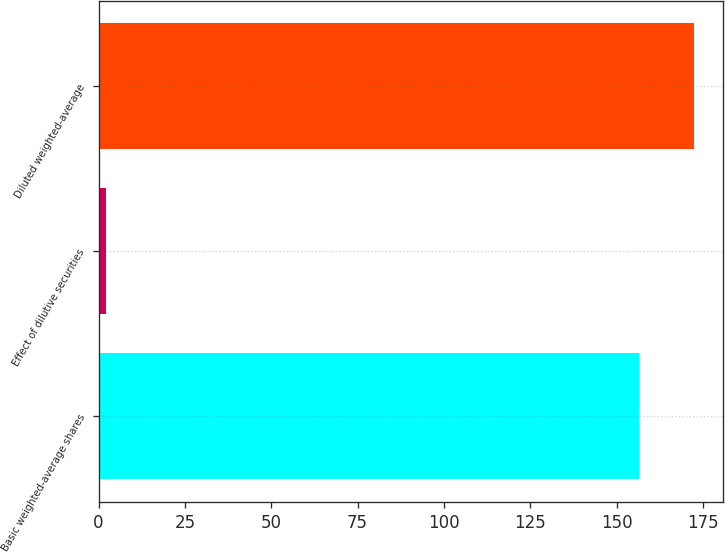<chart> <loc_0><loc_0><loc_500><loc_500><bar_chart><fcel>Basic weighted-average shares<fcel>Effect of dilutive securities<fcel>Diluted weighted-average<nl><fcel>156.6<fcel>2.1<fcel>172.26<nl></chart> 